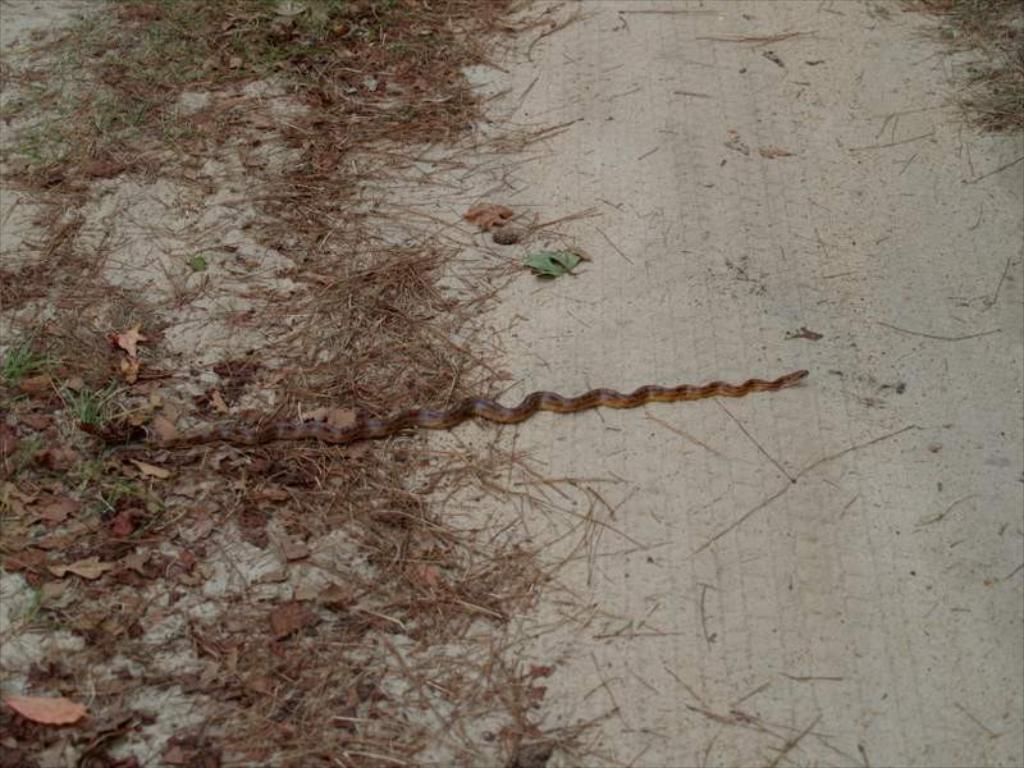How would you summarize this image in a sentence or two? In this picture we can see a snake and dried leaves on the ground. 